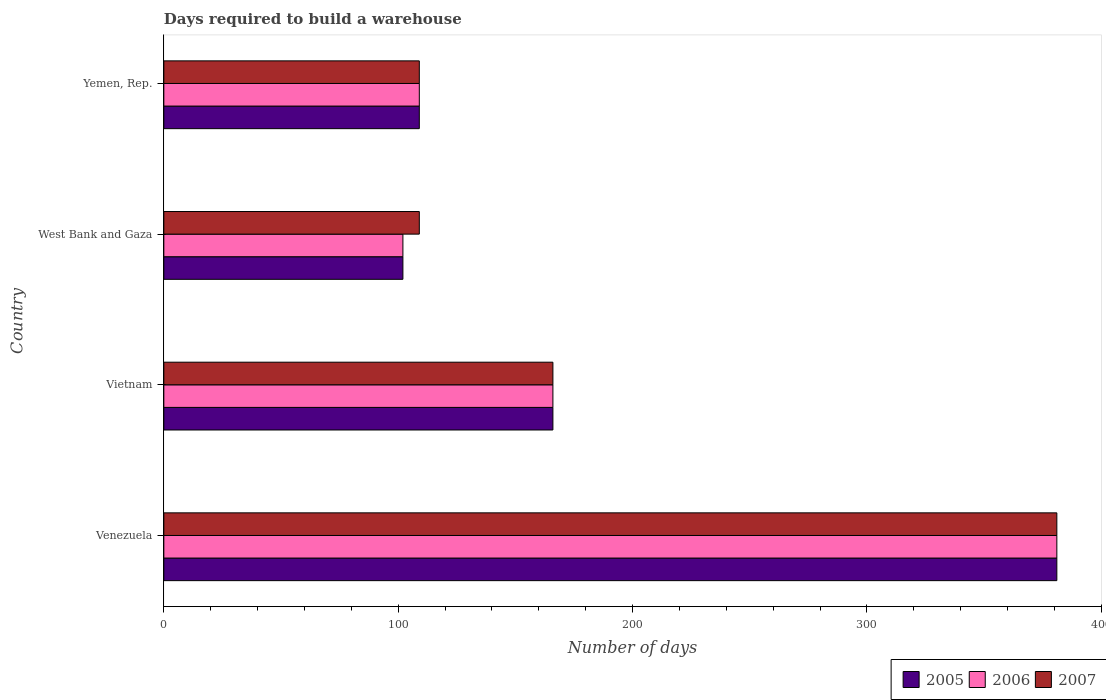How many different coloured bars are there?
Offer a very short reply. 3. How many groups of bars are there?
Keep it short and to the point. 4. Are the number of bars per tick equal to the number of legend labels?
Give a very brief answer. Yes. How many bars are there on the 3rd tick from the top?
Your answer should be compact. 3. What is the label of the 2nd group of bars from the top?
Make the answer very short. West Bank and Gaza. What is the days required to build a warehouse in in 2006 in Yemen, Rep.?
Your answer should be compact. 109. Across all countries, what is the maximum days required to build a warehouse in in 2007?
Provide a short and direct response. 381. Across all countries, what is the minimum days required to build a warehouse in in 2006?
Provide a short and direct response. 102. In which country was the days required to build a warehouse in in 2006 maximum?
Provide a short and direct response. Venezuela. In which country was the days required to build a warehouse in in 2007 minimum?
Your response must be concise. West Bank and Gaza. What is the total days required to build a warehouse in in 2006 in the graph?
Ensure brevity in your answer.  758. What is the difference between the days required to build a warehouse in in 2006 in Venezuela and that in Vietnam?
Your answer should be very brief. 215. What is the difference between the days required to build a warehouse in in 2006 in Yemen, Rep. and the days required to build a warehouse in in 2005 in Vietnam?
Your response must be concise. -57. What is the average days required to build a warehouse in in 2007 per country?
Your response must be concise. 191.25. In how many countries, is the days required to build a warehouse in in 2005 greater than 340 days?
Provide a succinct answer. 1. What is the ratio of the days required to build a warehouse in in 2006 in Vietnam to that in West Bank and Gaza?
Provide a succinct answer. 1.63. Is the days required to build a warehouse in in 2005 in West Bank and Gaza less than that in Yemen, Rep.?
Offer a terse response. Yes. What is the difference between the highest and the second highest days required to build a warehouse in in 2006?
Provide a succinct answer. 215. What is the difference between the highest and the lowest days required to build a warehouse in in 2006?
Provide a succinct answer. 279. In how many countries, is the days required to build a warehouse in in 2007 greater than the average days required to build a warehouse in in 2007 taken over all countries?
Give a very brief answer. 1. What does the 3rd bar from the top in Venezuela represents?
Your response must be concise. 2005. What does the 1st bar from the bottom in Yemen, Rep. represents?
Give a very brief answer. 2005. Is it the case that in every country, the sum of the days required to build a warehouse in in 2005 and days required to build a warehouse in in 2007 is greater than the days required to build a warehouse in in 2006?
Offer a very short reply. Yes. How many bars are there?
Give a very brief answer. 12. Are all the bars in the graph horizontal?
Your answer should be very brief. Yes. Does the graph contain any zero values?
Keep it short and to the point. No. Does the graph contain grids?
Your answer should be compact. No. How are the legend labels stacked?
Offer a very short reply. Horizontal. What is the title of the graph?
Make the answer very short. Days required to build a warehouse. What is the label or title of the X-axis?
Give a very brief answer. Number of days. What is the Number of days of 2005 in Venezuela?
Keep it short and to the point. 381. What is the Number of days in 2006 in Venezuela?
Your answer should be compact. 381. What is the Number of days of 2007 in Venezuela?
Keep it short and to the point. 381. What is the Number of days in 2005 in Vietnam?
Offer a terse response. 166. What is the Number of days in 2006 in Vietnam?
Make the answer very short. 166. What is the Number of days of 2007 in Vietnam?
Your answer should be very brief. 166. What is the Number of days in 2005 in West Bank and Gaza?
Your answer should be compact. 102. What is the Number of days of 2006 in West Bank and Gaza?
Your answer should be compact. 102. What is the Number of days of 2007 in West Bank and Gaza?
Your answer should be very brief. 109. What is the Number of days of 2005 in Yemen, Rep.?
Give a very brief answer. 109. What is the Number of days in 2006 in Yemen, Rep.?
Your response must be concise. 109. What is the Number of days in 2007 in Yemen, Rep.?
Your answer should be compact. 109. Across all countries, what is the maximum Number of days of 2005?
Offer a very short reply. 381. Across all countries, what is the maximum Number of days of 2006?
Provide a short and direct response. 381. Across all countries, what is the maximum Number of days in 2007?
Give a very brief answer. 381. Across all countries, what is the minimum Number of days in 2005?
Keep it short and to the point. 102. Across all countries, what is the minimum Number of days of 2006?
Provide a succinct answer. 102. Across all countries, what is the minimum Number of days in 2007?
Offer a terse response. 109. What is the total Number of days of 2005 in the graph?
Provide a short and direct response. 758. What is the total Number of days of 2006 in the graph?
Your answer should be compact. 758. What is the total Number of days of 2007 in the graph?
Your answer should be compact. 765. What is the difference between the Number of days of 2005 in Venezuela and that in Vietnam?
Offer a terse response. 215. What is the difference between the Number of days in 2006 in Venezuela and that in Vietnam?
Make the answer very short. 215. What is the difference between the Number of days of 2007 in Venezuela and that in Vietnam?
Provide a short and direct response. 215. What is the difference between the Number of days of 2005 in Venezuela and that in West Bank and Gaza?
Give a very brief answer. 279. What is the difference between the Number of days in 2006 in Venezuela and that in West Bank and Gaza?
Give a very brief answer. 279. What is the difference between the Number of days of 2007 in Venezuela and that in West Bank and Gaza?
Offer a very short reply. 272. What is the difference between the Number of days in 2005 in Venezuela and that in Yemen, Rep.?
Your response must be concise. 272. What is the difference between the Number of days in 2006 in Venezuela and that in Yemen, Rep.?
Your answer should be compact. 272. What is the difference between the Number of days in 2007 in Venezuela and that in Yemen, Rep.?
Ensure brevity in your answer.  272. What is the difference between the Number of days of 2006 in Vietnam and that in West Bank and Gaza?
Offer a terse response. 64. What is the difference between the Number of days in 2007 in Vietnam and that in West Bank and Gaza?
Make the answer very short. 57. What is the difference between the Number of days in 2006 in Vietnam and that in Yemen, Rep.?
Your response must be concise. 57. What is the difference between the Number of days of 2006 in West Bank and Gaza and that in Yemen, Rep.?
Keep it short and to the point. -7. What is the difference between the Number of days of 2005 in Venezuela and the Number of days of 2006 in Vietnam?
Your answer should be very brief. 215. What is the difference between the Number of days in 2005 in Venezuela and the Number of days in 2007 in Vietnam?
Give a very brief answer. 215. What is the difference between the Number of days in 2006 in Venezuela and the Number of days in 2007 in Vietnam?
Ensure brevity in your answer.  215. What is the difference between the Number of days in 2005 in Venezuela and the Number of days in 2006 in West Bank and Gaza?
Offer a terse response. 279. What is the difference between the Number of days of 2005 in Venezuela and the Number of days of 2007 in West Bank and Gaza?
Your answer should be compact. 272. What is the difference between the Number of days in 2006 in Venezuela and the Number of days in 2007 in West Bank and Gaza?
Give a very brief answer. 272. What is the difference between the Number of days of 2005 in Venezuela and the Number of days of 2006 in Yemen, Rep.?
Provide a short and direct response. 272. What is the difference between the Number of days of 2005 in Venezuela and the Number of days of 2007 in Yemen, Rep.?
Your answer should be compact. 272. What is the difference between the Number of days of 2006 in Venezuela and the Number of days of 2007 in Yemen, Rep.?
Ensure brevity in your answer.  272. What is the difference between the Number of days of 2006 in Vietnam and the Number of days of 2007 in West Bank and Gaza?
Your response must be concise. 57. What is the difference between the Number of days in 2006 in Vietnam and the Number of days in 2007 in Yemen, Rep.?
Provide a succinct answer. 57. What is the difference between the Number of days of 2005 in West Bank and Gaza and the Number of days of 2006 in Yemen, Rep.?
Offer a terse response. -7. What is the average Number of days of 2005 per country?
Give a very brief answer. 189.5. What is the average Number of days of 2006 per country?
Give a very brief answer. 189.5. What is the average Number of days in 2007 per country?
Your answer should be compact. 191.25. What is the difference between the Number of days of 2005 and Number of days of 2006 in Venezuela?
Your response must be concise. 0. What is the difference between the Number of days in 2005 and Number of days in 2007 in Venezuela?
Your response must be concise. 0. What is the difference between the Number of days of 2005 and Number of days of 2007 in West Bank and Gaza?
Make the answer very short. -7. What is the difference between the Number of days of 2006 and Number of days of 2007 in West Bank and Gaza?
Give a very brief answer. -7. What is the difference between the Number of days of 2005 and Number of days of 2006 in Yemen, Rep.?
Ensure brevity in your answer.  0. What is the difference between the Number of days in 2005 and Number of days in 2007 in Yemen, Rep.?
Your answer should be very brief. 0. What is the ratio of the Number of days in 2005 in Venezuela to that in Vietnam?
Give a very brief answer. 2.3. What is the ratio of the Number of days in 2006 in Venezuela to that in Vietnam?
Ensure brevity in your answer.  2.3. What is the ratio of the Number of days of 2007 in Venezuela to that in Vietnam?
Your response must be concise. 2.3. What is the ratio of the Number of days in 2005 in Venezuela to that in West Bank and Gaza?
Offer a terse response. 3.74. What is the ratio of the Number of days of 2006 in Venezuela to that in West Bank and Gaza?
Ensure brevity in your answer.  3.74. What is the ratio of the Number of days in 2007 in Venezuela to that in West Bank and Gaza?
Your answer should be compact. 3.5. What is the ratio of the Number of days in 2005 in Venezuela to that in Yemen, Rep.?
Give a very brief answer. 3.5. What is the ratio of the Number of days in 2006 in Venezuela to that in Yemen, Rep.?
Your response must be concise. 3.5. What is the ratio of the Number of days in 2007 in Venezuela to that in Yemen, Rep.?
Ensure brevity in your answer.  3.5. What is the ratio of the Number of days of 2005 in Vietnam to that in West Bank and Gaza?
Give a very brief answer. 1.63. What is the ratio of the Number of days in 2006 in Vietnam to that in West Bank and Gaza?
Provide a succinct answer. 1.63. What is the ratio of the Number of days in 2007 in Vietnam to that in West Bank and Gaza?
Give a very brief answer. 1.52. What is the ratio of the Number of days in 2005 in Vietnam to that in Yemen, Rep.?
Keep it short and to the point. 1.52. What is the ratio of the Number of days in 2006 in Vietnam to that in Yemen, Rep.?
Provide a short and direct response. 1.52. What is the ratio of the Number of days in 2007 in Vietnam to that in Yemen, Rep.?
Make the answer very short. 1.52. What is the ratio of the Number of days of 2005 in West Bank and Gaza to that in Yemen, Rep.?
Your response must be concise. 0.94. What is the ratio of the Number of days in 2006 in West Bank and Gaza to that in Yemen, Rep.?
Keep it short and to the point. 0.94. What is the difference between the highest and the second highest Number of days of 2005?
Your answer should be very brief. 215. What is the difference between the highest and the second highest Number of days in 2006?
Provide a succinct answer. 215. What is the difference between the highest and the second highest Number of days of 2007?
Offer a very short reply. 215. What is the difference between the highest and the lowest Number of days in 2005?
Ensure brevity in your answer.  279. What is the difference between the highest and the lowest Number of days of 2006?
Ensure brevity in your answer.  279. What is the difference between the highest and the lowest Number of days in 2007?
Provide a succinct answer. 272. 